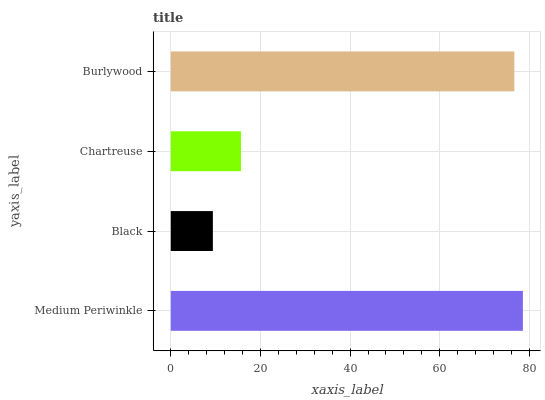Is Black the minimum?
Answer yes or no. Yes. Is Medium Periwinkle the maximum?
Answer yes or no. Yes. Is Chartreuse the minimum?
Answer yes or no. No. Is Chartreuse the maximum?
Answer yes or no. No. Is Chartreuse greater than Black?
Answer yes or no. Yes. Is Black less than Chartreuse?
Answer yes or no. Yes. Is Black greater than Chartreuse?
Answer yes or no. No. Is Chartreuse less than Black?
Answer yes or no. No. Is Burlywood the high median?
Answer yes or no. Yes. Is Chartreuse the low median?
Answer yes or no. Yes. Is Medium Periwinkle the high median?
Answer yes or no. No. Is Burlywood the low median?
Answer yes or no. No. 